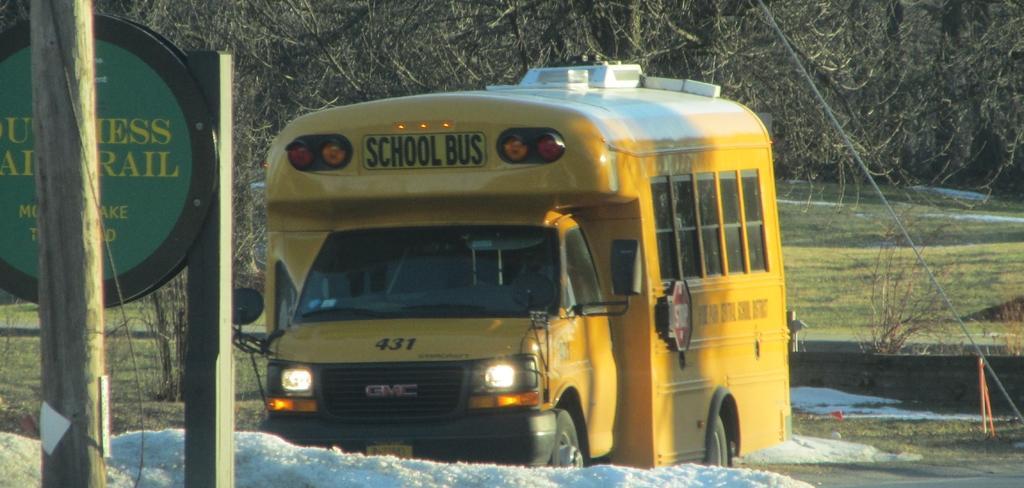In one or two sentences, can you explain what this image depicts? In this image I can see the vehicle in yellow color. In front I can see the board attached to the wooden pole, background I can see few trees. 